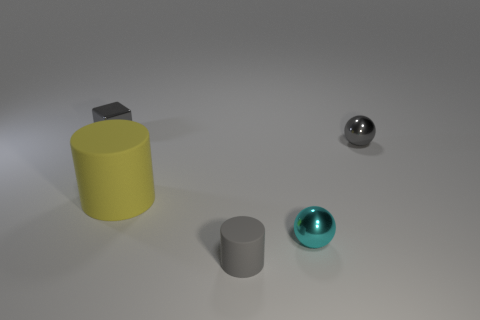There is a gray object that is to the left of the tiny cyan sphere and behind the cyan thing; what is its shape?
Ensure brevity in your answer.  Cube. There is a sphere that is the same color as the small shiny block; what is its material?
Make the answer very short. Metal. How many spheres are either gray objects or small cyan objects?
Your answer should be very brief. 2. There is a rubber object that is the same color as the small cube; what is its size?
Ensure brevity in your answer.  Small. Is the number of large cylinders that are in front of the big object less than the number of big red matte cylinders?
Make the answer very short. No. What is the color of the metal thing that is behind the big yellow matte cylinder and right of the yellow object?
Your response must be concise. Gray. How many other objects are the same shape as the big rubber object?
Your response must be concise. 1. Is the number of tiny cyan spheres that are behind the large yellow matte cylinder less than the number of gray objects left of the tiny gray matte cylinder?
Provide a succinct answer. Yes. Is the yellow thing made of the same material as the small block that is on the left side of the gray cylinder?
Offer a very short reply. No. Is the number of tiny metallic balls greater than the number of small gray matte cylinders?
Your response must be concise. Yes. 